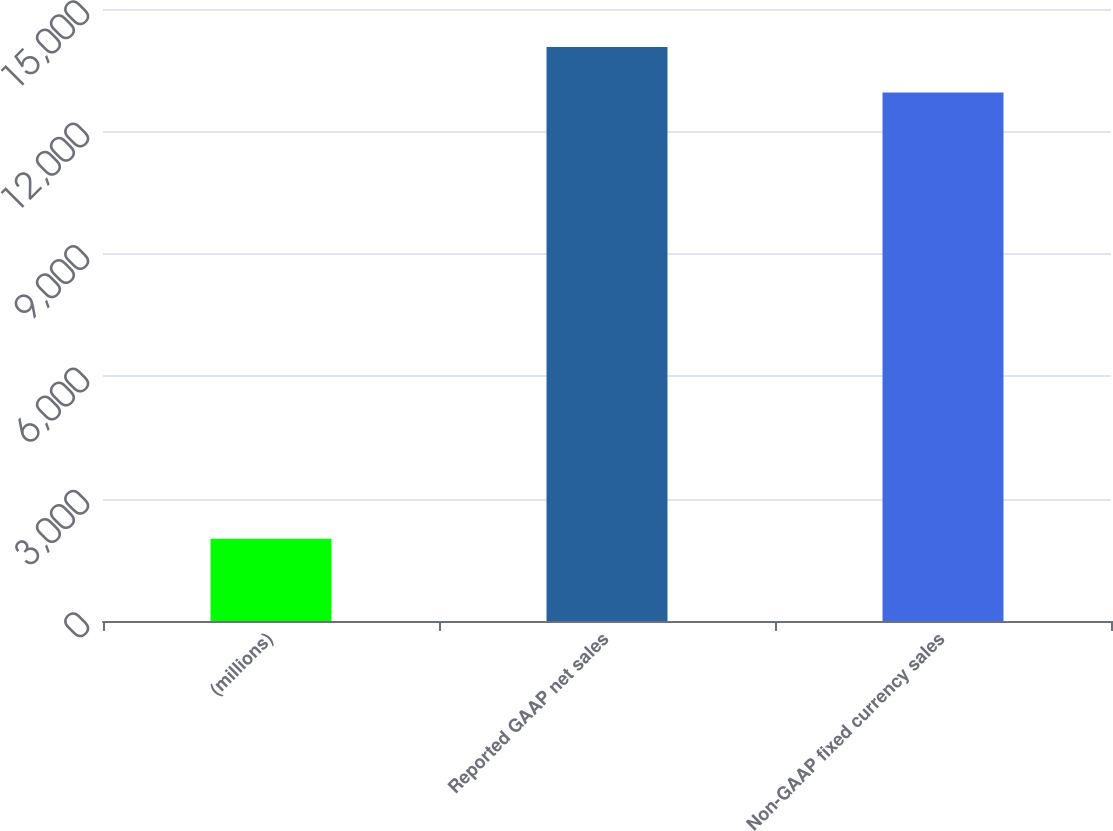Convert chart to OTSL. <chart><loc_0><loc_0><loc_500><loc_500><bar_chart><fcel>(millions)<fcel>Reported GAAP net sales<fcel>Non-GAAP fixed currency sales<nl><fcel>2016<fcel>14068.7<fcel>12955<nl></chart> 